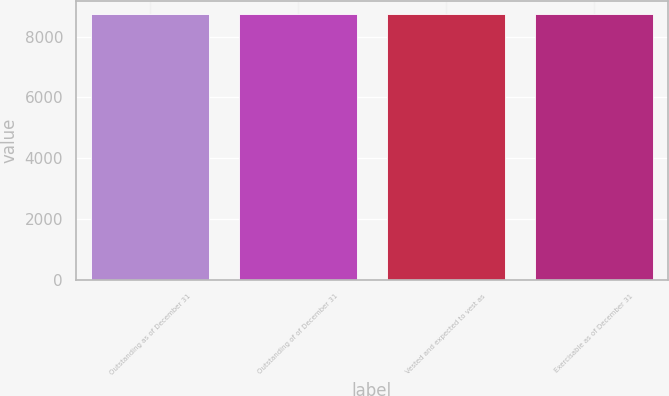<chart> <loc_0><loc_0><loc_500><loc_500><bar_chart><fcel>Outstanding as of December 31<fcel>Outstanding of of December 31<fcel>Vested and expected to vest as<fcel>Exercisable as of December 31<nl><fcel>8741<fcel>8741.1<fcel>8741.2<fcel>8741.3<nl></chart> 